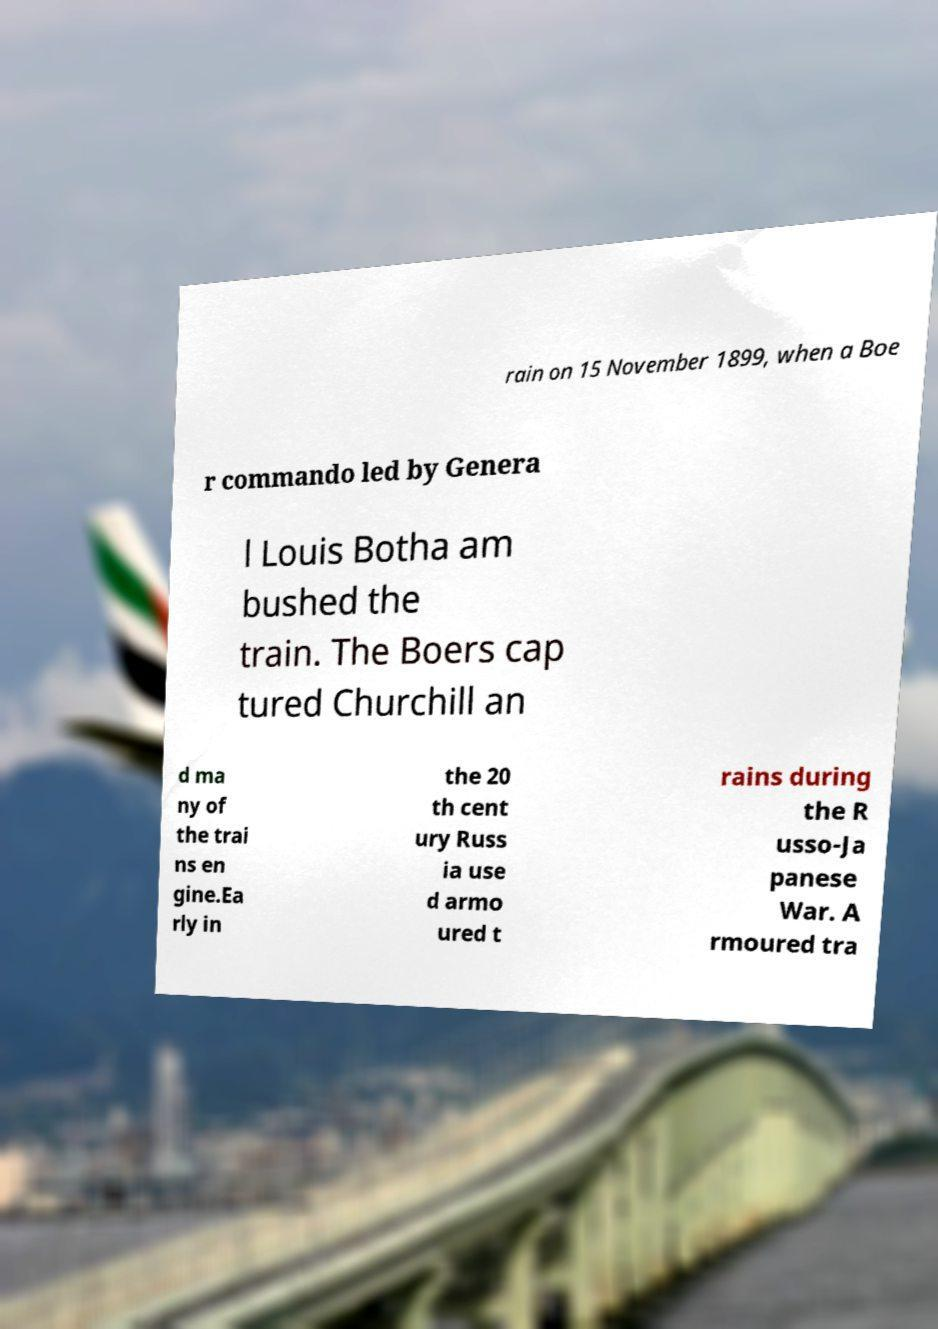Please identify and transcribe the text found in this image. rain on 15 November 1899, when a Boe r commando led by Genera l Louis Botha am bushed the train. The Boers cap tured Churchill an d ma ny of the trai ns en gine.Ea rly in the 20 th cent ury Russ ia use d armo ured t rains during the R usso-Ja panese War. A rmoured tra 